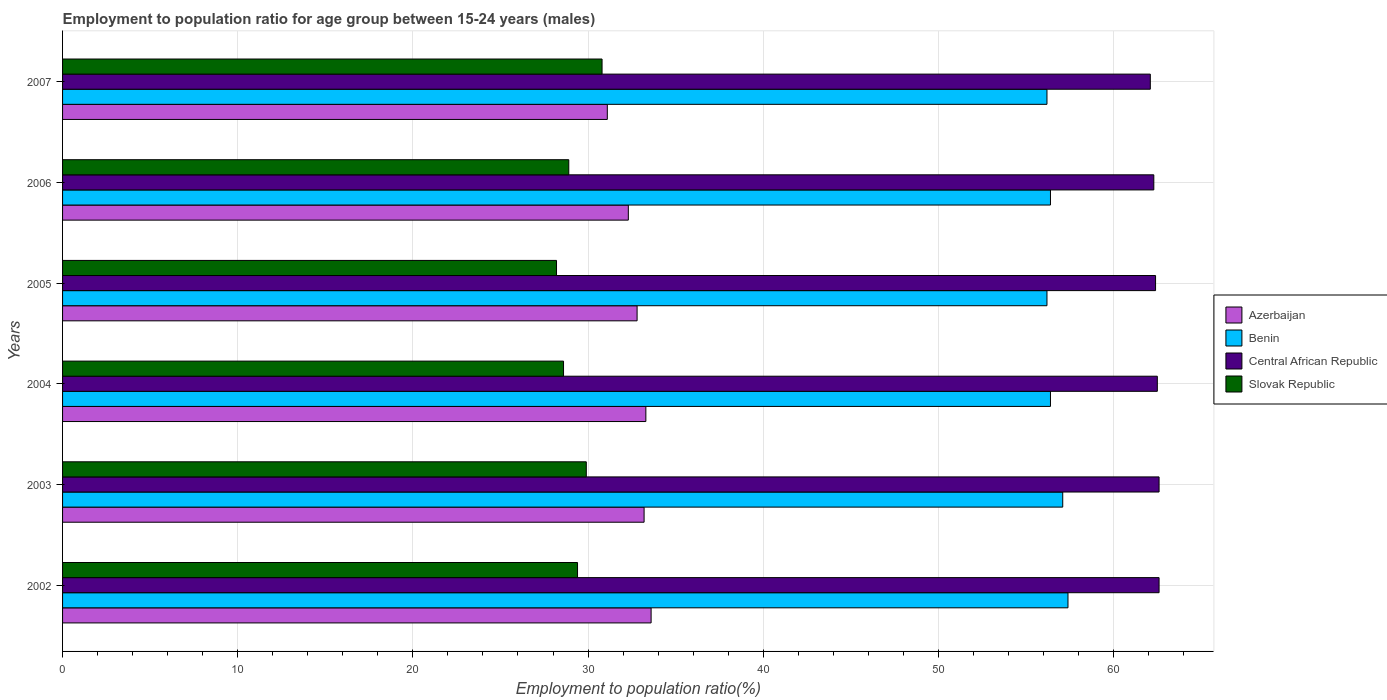Are the number of bars per tick equal to the number of legend labels?
Your response must be concise. Yes. In how many cases, is the number of bars for a given year not equal to the number of legend labels?
Ensure brevity in your answer.  0. What is the employment to population ratio in Benin in 2003?
Offer a very short reply. 57.1. Across all years, what is the maximum employment to population ratio in Azerbaijan?
Your response must be concise. 33.6. Across all years, what is the minimum employment to population ratio in Benin?
Your answer should be compact. 56.2. In which year was the employment to population ratio in Slovak Republic minimum?
Provide a succinct answer. 2005. What is the total employment to population ratio in Azerbaijan in the graph?
Give a very brief answer. 196.3. What is the difference between the employment to population ratio in Slovak Republic in 2003 and that in 2006?
Give a very brief answer. 1. What is the difference between the employment to population ratio in Central African Republic in 2007 and the employment to population ratio in Benin in 2002?
Offer a very short reply. 4.7. What is the average employment to population ratio in Benin per year?
Keep it short and to the point. 56.62. In the year 2007, what is the difference between the employment to population ratio in Slovak Republic and employment to population ratio in Benin?
Your answer should be very brief. -25.4. Is the difference between the employment to population ratio in Slovak Republic in 2002 and 2005 greater than the difference between the employment to population ratio in Benin in 2002 and 2005?
Offer a very short reply. No. What is the difference between the highest and the second highest employment to population ratio in Azerbaijan?
Offer a very short reply. 0.3. In how many years, is the employment to population ratio in Slovak Republic greater than the average employment to population ratio in Slovak Republic taken over all years?
Offer a terse response. 3. Is the sum of the employment to population ratio in Benin in 2004 and 2006 greater than the maximum employment to population ratio in Central African Republic across all years?
Your answer should be very brief. Yes. What does the 4th bar from the top in 2007 represents?
Your answer should be very brief. Azerbaijan. What does the 1st bar from the bottom in 2004 represents?
Your answer should be compact. Azerbaijan. Is it the case that in every year, the sum of the employment to population ratio in Central African Republic and employment to population ratio in Azerbaijan is greater than the employment to population ratio in Benin?
Offer a terse response. Yes. How many bars are there?
Ensure brevity in your answer.  24. Are the values on the major ticks of X-axis written in scientific E-notation?
Offer a very short reply. No. Does the graph contain grids?
Your answer should be very brief. Yes. Where does the legend appear in the graph?
Give a very brief answer. Center right. How are the legend labels stacked?
Give a very brief answer. Vertical. What is the title of the graph?
Provide a short and direct response. Employment to population ratio for age group between 15-24 years (males). What is the label or title of the X-axis?
Provide a short and direct response. Employment to population ratio(%). What is the Employment to population ratio(%) of Azerbaijan in 2002?
Offer a terse response. 33.6. What is the Employment to population ratio(%) of Benin in 2002?
Keep it short and to the point. 57.4. What is the Employment to population ratio(%) in Central African Republic in 2002?
Your response must be concise. 62.6. What is the Employment to population ratio(%) of Slovak Republic in 2002?
Offer a very short reply. 29.4. What is the Employment to population ratio(%) in Azerbaijan in 2003?
Your answer should be compact. 33.2. What is the Employment to population ratio(%) of Benin in 2003?
Provide a short and direct response. 57.1. What is the Employment to population ratio(%) in Central African Republic in 2003?
Keep it short and to the point. 62.6. What is the Employment to population ratio(%) of Slovak Republic in 2003?
Your response must be concise. 29.9. What is the Employment to population ratio(%) of Azerbaijan in 2004?
Your answer should be very brief. 33.3. What is the Employment to population ratio(%) of Benin in 2004?
Your answer should be very brief. 56.4. What is the Employment to population ratio(%) in Central African Republic in 2004?
Offer a terse response. 62.5. What is the Employment to population ratio(%) of Slovak Republic in 2004?
Provide a succinct answer. 28.6. What is the Employment to population ratio(%) of Azerbaijan in 2005?
Keep it short and to the point. 32.8. What is the Employment to population ratio(%) in Benin in 2005?
Your answer should be compact. 56.2. What is the Employment to population ratio(%) in Central African Republic in 2005?
Provide a succinct answer. 62.4. What is the Employment to population ratio(%) in Slovak Republic in 2005?
Provide a succinct answer. 28.2. What is the Employment to population ratio(%) of Azerbaijan in 2006?
Keep it short and to the point. 32.3. What is the Employment to population ratio(%) of Benin in 2006?
Offer a very short reply. 56.4. What is the Employment to population ratio(%) in Central African Republic in 2006?
Offer a very short reply. 62.3. What is the Employment to population ratio(%) of Slovak Republic in 2006?
Provide a succinct answer. 28.9. What is the Employment to population ratio(%) in Azerbaijan in 2007?
Provide a succinct answer. 31.1. What is the Employment to population ratio(%) of Benin in 2007?
Offer a terse response. 56.2. What is the Employment to population ratio(%) in Central African Republic in 2007?
Offer a terse response. 62.1. What is the Employment to population ratio(%) in Slovak Republic in 2007?
Your response must be concise. 30.8. Across all years, what is the maximum Employment to population ratio(%) of Azerbaijan?
Provide a succinct answer. 33.6. Across all years, what is the maximum Employment to population ratio(%) of Benin?
Your answer should be very brief. 57.4. Across all years, what is the maximum Employment to population ratio(%) of Central African Republic?
Your answer should be very brief. 62.6. Across all years, what is the maximum Employment to population ratio(%) in Slovak Republic?
Keep it short and to the point. 30.8. Across all years, what is the minimum Employment to population ratio(%) of Azerbaijan?
Your answer should be compact. 31.1. Across all years, what is the minimum Employment to population ratio(%) of Benin?
Give a very brief answer. 56.2. Across all years, what is the minimum Employment to population ratio(%) in Central African Republic?
Provide a succinct answer. 62.1. Across all years, what is the minimum Employment to population ratio(%) in Slovak Republic?
Provide a short and direct response. 28.2. What is the total Employment to population ratio(%) of Azerbaijan in the graph?
Offer a very short reply. 196.3. What is the total Employment to population ratio(%) in Benin in the graph?
Offer a very short reply. 339.7. What is the total Employment to population ratio(%) of Central African Republic in the graph?
Offer a very short reply. 374.5. What is the total Employment to population ratio(%) in Slovak Republic in the graph?
Offer a very short reply. 175.8. What is the difference between the Employment to population ratio(%) in Azerbaijan in 2002 and that in 2003?
Ensure brevity in your answer.  0.4. What is the difference between the Employment to population ratio(%) of Slovak Republic in 2002 and that in 2003?
Keep it short and to the point. -0.5. What is the difference between the Employment to population ratio(%) of Benin in 2002 and that in 2004?
Provide a succinct answer. 1. What is the difference between the Employment to population ratio(%) in Central African Republic in 2002 and that in 2005?
Offer a terse response. 0.2. What is the difference between the Employment to population ratio(%) in Slovak Republic in 2002 and that in 2005?
Your response must be concise. 1.2. What is the difference between the Employment to population ratio(%) in Benin in 2002 and that in 2006?
Ensure brevity in your answer.  1. What is the difference between the Employment to population ratio(%) in Central African Republic in 2002 and that in 2006?
Your answer should be compact. 0.3. What is the difference between the Employment to population ratio(%) of Slovak Republic in 2002 and that in 2006?
Your response must be concise. 0.5. What is the difference between the Employment to population ratio(%) of Benin in 2003 and that in 2004?
Your response must be concise. 0.7. What is the difference between the Employment to population ratio(%) in Central African Republic in 2003 and that in 2004?
Your answer should be very brief. 0.1. What is the difference between the Employment to population ratio(%) in Azerbaijan in 2003 and that in 2005?
Your answer should be compact. 0.4. What is the difference between the Employment to population ratio(%) in Benin in 2003 and that in 2005?
Keep it short and to the point. 0.9. What is the difference between the Employment to population ratio(%) of Central African Republic in 2003 and that in 2005?
Keep it short and to the point. 0.2. What is the difference between the Employment to population ratio(%) of Azerbaijan in 2003 and that in 2006?
Keep it short and to the point. 0.9. What is the difference between the Employment to population ratio(%) in Central African Republic in 2003 and that in 2006?
Provide a succinct answer. 0.3. What is the difference between the Employment to population ratio(%) in Benin in 2003 and that in 2007?
Your answer should be very brief. 0.9. What is the difference between the Employment to population ratio(%) in Central African Republic in 2003 and that in 2007?
Provide a succinct answer. 0.5. What is the difference between the Employment to population ratio(%) of Slovak Republic in 2003 and that in 2007?
Your response must be concise. -0.9. What is the difference between the Employment to population ratio(%) of Benin in 2004 and that in 2005?
Your answer should be very brief. 0.2. What is the difference between the Employment to population ratio(%) in Central African Republic in 2004 and that in 2005?
Offer a terse response. 0.1. What is the difference between the Employment to population ratio(%) in Benin in 2004 and that in 2006?
Provide a succinct answer. 0. What is the difference between the Employment to population ratio(%) in Central African Republic in 2004 and that in 2006?
Your answer should be very brief. 0.2. What is the difference between the Employment to population ratio(%) in Azerbaijan in 2004 and that in 2007?
Your answer should be very brief. 2.2. What is the difference between the Employment to population ratio(%) of Central African Republic in 2004 and that in 2007?
Make the answer very short. 0.4. What is the difference between the Employment to population ratio(%) of Azerbaijan in 2005 and that in 2006?
Offer a very short reply. 0.5. What is the difference between the Employment to population ratio(%) in Benin in 2005 and that in 2006?
Offer a very short reply. -0.2. What is the difference between the Employment to population ratio(%) of Slovak Republic in 2005 and that in 2006?
Provide a succinct answer. -0.7. What is the difference between the Employment to population ratio(%) of Benin in 2005 and that in 2007?
Make the answer very short. 0. What is the difference between the Employment to population ratio(%) of Slovak Republic in 2005 and that in 2007?
Provide a short and direct response. -2.6. What is the difference between the Employment to population ratio(%) of Benin in 2006 and that in 2007?
Keep it short and to the point. 0.2. What is the difference between the Employment to population ratio(%) in Central African Republic in 2006 and that in 2007?
Offer a very short reply. 0.2. What is the difference between the Employment to population ratio(%) of Slovak Republic in 2006 and that in 2007?
Keep it short and to the point. -1.9. What is the difference between the Employment to population ratio(%) in Azerbaijan in 2002 and the Employment to population ratio(%) in Benin in 2003?
Ensure brevity in your answer.  -23.5. What is the difference between the Employment to population ratio(%) of Azerbaijan in 2002 and the Employment to population ratio(%) of Central African Republic in 2003?
Make the answer very short. -29. What is the difference between the Employment to population ratio(%) of Benin in 2002 and the Employment to population ratio(%) of Slovak Republic in 2003?
Keep it short and to the point. 27.5. What is the difference between the Employment to population ratio(%) of Central African Republic in 2002 and the Employment to population ratio(%) of Slovak Republic in 2003?
Your answer should be compact. 32.7. What is the difference between the Employment to population ratio(%) of Azerbaijan in 2002 and the Employment to population ratio(%) of Benin in 2004?
Ensure brevity in your answer.  -22.8. What is the difference between the Employment to population ratio(%) in Azerbaijan in 2002 and the Employment to population ratio(%) in Central African Republic in 2004?
Your answer should be compact. -28.9. What is the difference between the Employment to population ratio(%) in Benin in 2002 and the Employment to population ratio(%) in Central African Republic in 2004?
Make the answer very short. -5.1. What is the difference between the Employment to population ratio(%) of Benin in 2002 and the Employment to population ratio(%) of Slovak Republic in 2004?
Offer a terse response. 28.8. What is the difference between the Employment to population ratio(%) of Central African Republic in 2002 and the Employment to population ratio(%) of Slovak Republic in 2004?
Offer a very short reply. 34. What is the difference between the Employment to population ratio(%) of Azerbaijan in 2002 and the Employment to population ratio(%) of Benin in 2005?
Offer a terse response. -22.6. What is the difference between the Employment to population ratio(%) in Azerbaijan in 2002 and the Employment to population ratio(%) in Central African Republic in 2005?
Keep it short and to the point. -28.8. What is the difference between the Employment to population ratio(%) in Azerbaijan in 2002 and the Employment to population ratio(%) in Slovak Republic in 2005?
Provide a short and direct response. 5.4. What is the difference between the Employment to population ratio(%) of Benin in 2002 and the Employment to population ratio(%) of Central African Republic in 2005?
Your response must be concise. -5. What is the difference between the Employment to population ratio(%) in Benin in 2002 and the Employment to population ratio(%) in Slovak Republic in 2005?
Offer a terse response. 29.2. What is the difference between the Employment to population ratio(%) of Central African Republic in 2002 and the Employment to population ratio(%) of Slovak Republic in 2005?
Ensure brevity in your answer.  34.4. What is the difference between the Employment to population ratio(%) of Azerbaijan in 2002 and the Employment to population ratio(%) of Benin in 2006?
Provide a succinct answer. -22.8. What is the difference between the Employment to population ratio(%) in Azerbaijan in 2002 and the Employment to population ratio(%) in Central African Republic in 2006?
Your answer should be compact. -28.7. What is the difference between the Employment to population ratio(%) of Azerbaijan in 2002 and the Employment to population ratio(%) of Slovak Republic in 2006?
Your response must be concise. 4.7. What is the difference between the Employment to population ratio(%) in Benin in 2002 and the Employment to population ratio(%) in Slovak Republic in 2006?
Keep it short and to the point. 28.5. What is the difference between the Employment to population ratio(%) of Central African Republic in 2002 and the Employment to population ratio(%) of Slovak Republic in 2006?
Give a very brief answer. 33.7. What is the difference between the Employment to population ratio(%) of Azerbaijan in 2002 and the Employment to population ratio(%) of Benin in 2007?
Your answer should be compact. -22.6. What is the difference between the Employment to population ratio(%) in Azerbaijan in 2002 and the Employment to population ratio(%) in Central African Republic in 2007?
Give a very brief answer. -28.5. What is the difference between the Employment to population ratio(%) of Azerbaijan in 2002 and the Employment to population ratio(%) of Slovak Republic in 2007?
Ensure brevity in your answer.  2.8. What is the difference between the Employment to population ratio(%) of Benin in 2002 and the Employment to population ratio(%) of Slovak Republic in 2007?
Make the answer very short. 26.6. What is the difference between the Employment to population ratio(%) in Central African Republic in 2002 and the Employment to population ratio(%) in Slovak Republic in 2007?
Offer a very short reply. 31.8. What is the difference between the Employment to population ratio(%) in Azerbaijan in 2003 and the Employment to population ratio(%) in Benin in 2004?
Offer a very short reply. -23.2. What is the difference between the Employment to population ratio(%) of Azerbaijan in 2003 and the Employment to population ratio(%) of Central African Republic in 2004?
Offer a very short reply. -29.3. What is the difference between the Employment to population ratio(%) in Azerbaijan in 2003 and the Employment to population ratio(%) in Slovak Republic in 2004?
Your answer should be very brief. 4.6. What is the difference between the Employment to population ratio(%) in Benin in 2003 and the Employment to population ratio(%) in Central African Republic in 2004?
Your answer should be compact. -5.4. What is the difference between the Employment to population ratio(%) in Azerbaijan in 2003 and the Employment to population ratio(%) in Benin in 2005?
Your response must be concise. -23. What is the difference between the Employment to population ratio(%) in Azerbaijan in 2003 and the Employment to population ratio(%) in Central African Republic in 2005?
Ensure brevity in your answer.  -29.2. What is the difference between the Employment to population ratio(%) in Azerbaijan in 2003 and the Employment to population ratio(%) in Slovak Republic in 2005?
Your response must be concise. 5. What is the difference between the Employment to population ratio(%) of Benin in 2003 and the Employment to population ratio(%) of Slovak Republic in 2005?
Give a very brief answer. 28.9. What is the difference between the Employment to population ratio(%) in Central African Republic in 2003 and the Employment to population ratio(%) in Slovak Republic in 2005?
Provide a succinct answer. 34.4. What is the difference between the Employment to population ratio(%) of Azerbaijan in 2003 and the Employment to population ratio(%) of Benin in 2006?
Your response must be concise. -23.2. What is the difference between the Employment to population ratio(%) in Azerbaijan in 2003 and the Employment to population ratio(%) in Central African Republic in 2006?
Give a very brief answer. -29.1. What is the difference between the Employment to population ratio(%) of Benin in 2003 and the Employment to population ratio(%) of Slovak Republic in 2006?
Your response must be concise. 28.2. What is the difference between the Employment to population ratio(%) in Central African Republic in 2003 and the Employment to population ratio(%) in Slovak Republic in 2006?
Your response must be concise. 33.7. What is the difference between the Employment to population ratio(%) in Azerbaijan in 2003 and the Employment to population ratio(%) in Benin in 2007?
Offer a terse response. -23. What is the difference between the Employment to population ratio(%) of Azerbaijan in 2003 and the Employment to population ratio(%) of Central African Republic in 2007?
Your response must be concise. -28.9. What is the difference between the Employment to population ratio(%) in Benin in 2003 and the Employment to population ratio(%) in Slovak Republic in 2007?
Provide a succinct answer. 26.3. What is the difference between the Employment to population ratio(%) in Central African Republic in 2003 and the Employment to population ratio(%) in Slovak Republic in 2007?
Offer a very short reply. 31.8. What is the difference between the Employment to population ratio(%) of Azerbaijan in 2004 and the Employment to population ratio(%) of Benin in 2005?
Your response must be concise. -22.9. What is the difference between the Employment to population ratio(%) in Azerbaijan in 2004 and the Employment to population ratio(%) in Central African Republic in 2005?
Give a very brief answer. -29.1. What is the difference between the Employment to population ratio(%) in Benin in 2004 and the Employment to population ratio(%) in Central African Republic in 2005?
Make the answer very short. -6. What is the difference between the Employment to population ratio(%) of Benin in 2004 and the Employment to population ratio(%) of Slovak Republic in 2005?
Ensure brevity in your answer.  28.2. What is the difference between the Employment to population ratio(%) of Central African Republic in 2004 and the Employment to population ratio(%) of Slovak Republic in 2005?
Your response must be concise. 34.3. What is the difference between the Employment to population ratio(%) in Azerbaijan in 2004 and the Employment to population ratio(%) in Benin in 2006?
Your answer should be compact. -23.1. What is the difference between the Employment to population ratio(%) in Azerbaijan in 2004 and the Employment to population ratio(%) in Slovak Republic in 2006?
Offer a very short reply. 4.4. What is the difference between the Employment to population ratio(%) in Benin in 2004 and the Employment to population ratio(%) in Central African Republic in 2006?
Your answer should be compact. -5.9. What is the difference between the Employment to population ratio(%) in Central African Republic in 2004 and the Employment to population ratio(%) in Slovak Republic in 2006?
Offer a very short reply. 33.6. What is the difference between the Employment to population ratio(%) in Azerbaijan in 2004 and the Employment to population ratio(%) in Benin in 2007?
Offer a terse response. -22.9. What is the difference between the Employment to population ratio(%) in Azerbaijan in 2004 and the Employment to population ratio(%) in Central African Republic in 2007?
Provide a short and direct response. -28.8. What is the difference between the Employment to population ratio(%) of Benin in 2004 and the Employment to population ratio(%) of Central African Republic in 2007?
Offer a terse response. -5.7. What is the difference between the Employment to population ratio(%) in Benin in 2004 and the Employment to population ratio(%) in Slovak Republic in 2007?
Your answer should be very brief. 25.6. What is the difference between the Employment to population ratio(%) in Central African Republic in 2004 and the Employment to population ratio(%) in Slovak Republic in 2007?
Provide a short and direct response. 31.7. What is the difference between the Employment to population ratio(%) in Azerbaijan in 2005 and the Employment to population ratio(%) in Benin in 2006?
Provide a succinct answer. -23.6. What is the difference between the Employment to population ratio(%) of Azerbaijan in 2005 and the Employment to population ratio(%) of Central African Republic in 2006?
Keep it short and to the point. -29.5. What is the difference between the Employment to population ratio(%) of Benin in 2005 and the Employment to population ratio(%) of Central African Republic in 2006?
Ensure brevity in your answer.  -6.1. What is the difference between the Employment to population ratio(%) in Benin in 2005 and the Employment to population ratio(%) in Slovak Republic in 2006?
Ensure brevity in your answer.  27.3. What is the difference between the Employment to population ratio(%) in Central African Republic in 2005 and the Employment to population ratio(%) in Slovak Republic in 2006?
Offer a terse response. 33.5. What is the difference between the Employment to population ratio(%) in Azerbaijan in 2005 and the Employment to population ratio(%) in Benin in 2007?
Keep it short and to the point. -23.4. What is the difference between the Employment to population ratio(%) in Azerbaijan in 2005 and the Employment to population ratio(%) in Central African Republic in 2007?
Keep it short and to the point. -29.3. What is the difference between the Employment to population ratio(%) of Benin in 2005 and the Employment to population ratio(%) of Central African Republic in 2007?
Your response must be concise. -5.9. What is the difference between the Employment to population ratio(%) of Benin in 2005 and the Employment to population ratio(%) of Slovak Republic in 2007?
Keep it short and to the point. 25.4. What is the difference between the Employment to population ratio(%) of Central African Republic in 2005 and the Employment to population ratio(%) of Slovak Republic in 2007?
Your answer should be very brief. 31.6. What is the difference between the Employment to population ratio(%) in Azerbaijan in 2006 and the Employment to population ratio(%) in Benin in 2007?
Make the answer very short. -23.9. What is the difference between the Employment to population ratio(%) of Azerbaijan in 2006 and the Employment to population ratio(%) of Central African Republic in 2007?
Your answer should be very brief. -29.8. What is the difference between the Employment to population ratio(%) of Azerbaijan in 2006 and the Employment to population ratio(%) of Slovak Republic in 2007?
Your answer should be very brief. 1.5. What is the difference between the Employment to population ratio(%) of Benin in 2006 and the Employment to population ratio(%) of Slovak Republic in 2007?
Provide a succinct answer. 25.6. What is the difference between the Employment to population ratio(%) of Central African Republic in 2006 and the Employment to population ratio(%) of Slovak Republic in 2007?
Give a very brief answer. 31.5. What is the average Employment to population ratio(%) in Azerbaijan per year?
Your response must be concise. 32.72. What is the average Employment to population ratio(%) of Benin per year?
Your response must be concise. 56.62. What is the average Employment to population ratio(%) of Central African Republic per year?
Offer a very short reply. 62.42. What is the average Employment to population ratio(%) of Slovak Republic per year?
Make the answer very short. 29.3. In the year 2002, what is the difference between the Employment to population ratio(%) in Azerbaijan and Employment to population ratio(%) in Benin?
Provide a succinct answer. -23.8. In the year 2002, what is the difference between the Employment to population ratio(%) in Benin and Employment to population ratio(%) in Slovak Republic?
Your answer should be very brief. 28. In the year 2002, what is the difference between the Employment to population ratio(%) of Central African Republic and Employment to population ratio(%) of Slovak Republic?
Your response must be concise. 33.2. In the year 2003, what is the difference between the Employment to population ratio(%) in Azerbaijan and Employment to population ratio(%) in Benin?
Make the answer very short. -23.9. In the year 2003, what is the difference between the Employment to population ratio(%) in Azerbaijan and Employment to population ratio(%) in Central African Republic?
Your answer should be compact. -29.4. In the year 2003, what is the difference between the Employment to population ratio(%) in Benin and Employment to population ratio(%) in Central African Republic?
Offer a very short reply. -5.5. In the year 2003, what is the difference between the Employment to population ratio(%) in Benin and Employment to population ratio(%) in Slovak Republic?
Provide a short and direct response. 27.2. In the year 2003, what is the difference between the Employment to population ratio(%) in Central African Republic and Employment to population ratio(%) in Slovak Republic?
Provide a succinct answer. 32.7. In the year 2004, what is the difference between the Employment to population ratio(%) of Azerbaijan and Employment to population ratio(%) of Benin?
Ensure brevity in your answer.  -23.1. In the year 2004, what is the difference between the Employment to population ratio(%) of Azerbaijan and Employment to population ratio(%) of Central African Republic?
Offer a very short reply. -29.2. In the year 2004, what is the difference between the Employment to population ratio(%) in Benin and Employment to population ratio(%) in Central African Republic?
Offer a very short reply. -6.1. In the year 2004, what is the difference between the Employment to population ratio(%) of Benin and Employment to population ratio(%) of Slovak Republic?
Your answer should be compact. 27.8. In the year 2004, what is the difference between the Employment to population ratio(%) of Central African Republic and Employment to population ratio(%) of Slovak Republic?
Provide a succinct answer. 33.9. In the year 2005, what is the difference between the Employment to population ratio(%) in Azerbaijan and Employment to population ratio(%) in Benin?
Offer a terse response. -23.4. In the year 2005, what is the difference between the Employment to population ratio(%) in Azerbaijan and Employment to population ratio(%) in Central African Republic?
Your answer should be very brief. -29.6. In the year 2005, what is the difference between the Employment to population ratio(%) in Azerbaijan and Employment to population ratio(%) in Slovak Republic?
Give a very brief answer. 4.6. In the year 2005, what is the difference between the Employment to population ratio(%) of Benin and Employment to population ratio(%) of Central African Republic?
Give a very brief answer. -6.2. In the year 2005, what is the difference between the Employment to population ratio(%) in Central African Republic and Employment to population ratio(%) in Slovak Republic?
Provide a succinct answer. 34.2. In the year 2006, what is the difference between the Employment to population ratio(%) of Azerbaijan and Employment to population ratio(%) of Benin?
Your answer should be very brief. -24.1. In the year 2006, what is the difference between the Employment to population ratio(%) of Azerbaijan and Employment to population ratio(%) of Slovak Republic?
Your response must be concise. 3.4. In the year 2006, what is the difference between the Employment to population ratio(%) in Benin and Employment to population ratio(%) in Central African Republic?
Your answer should be compact. -5.9. In the year 2006, what is the difference between the Employment to population ratio(%) in Central African Republic and Employment to population ratio(%) in Slovak Republic?
Offer a very short reply. 33.4. In the year 2007, what is the difference between the Employment to population ratio(%) of Azerbaijan and Employment to population ratio(%) of Benin?
Offer a very short reply. -25.1. In the year 2007, what is the difference between the Employment to population ratio(%) of Azerbaijan and Employment to population ratio(%) of Central African Republic?
Keep it short and to the point. -31. In the year 2007, what is the difference between the Employment to population ratio(%) of Azerbaijan and Employment to population ratio(%) of Slovak Republic?
Your response must be concise. 0.3. In the year 2007, what is the difference between the Employment to population ratio(%) in Benin and Employment to population ratio(%) in Central African Republic?
Your response must be concise. -5.9. In the year 2007, what is the difference between the Employment to population ratio(%) of Benin and Employment to population ratio(%) of Slovak Republic?
Your answer should be compact. 25.4. In the year 2007, what is the difference between the Employment to population ratio(%) in Central African Republic and Employment to population ratio(%) in Slovak Republic?
Provide a succinct answer. 31.3. What is the ratio of the Employment to population ratio(%) in Azerbaijan in 2002 to that in 2003?
Offer a very short reply. 1.01. What is the ratio of the Employment to population ratio(%) of Slovak Republic in 2002 to that in 2003?
Make the answer very short. 0.98. What is the ratio of the Employment to population ratio(%) of Azerbaijan in 2002 to that in 2004?
Offer a very short reply. 1.01. What is the ratio of the Employment to population ratio(%) in Benin in 2002 to that in 2004?
Keep it short and to the point. 1.02. What is the ratio of the Employment to population ratio(%) in Central African Republic in 2002 to that in 2004?
Make the answer very short. 1. What is the ratio of the Employment to population ratio(%) of Slovak Republic in 2002 to that in 2004?
Make the answer very short. 1.03. What is the ratio of the Employment to population ratio(%) of Azerbaijan in 2002 to that in 2005?
Make the answer very short. 1.02. What is the ratio of the Employment to population ratio(%) in Benin in 2002 to that in 2005?
Your answer should be compact. 1.02. What is the ratio of the Employment to population ratio(%) of Slovak Republic in 2002 to that in 2005?
Your response must be concise. 1.04. What is the ratio of the Employment to population ratio(%) in Azerbaijan in 2002 to that in 2006?
Your answer should be compact. 1.04. What is the ratio of the Employment to population ratio(%) in Benin in 2002 to that in 2006?
Provide a short and direct response. 1.02. What is the ratio of the Employment to population ratio(%) of Slovak Republic in 2002 to that in 2006?
Offer a terse response. 1.02. What is the ratio of the Employment to population ratio(%) of Azerbaijan in 2002 to that in 2007?
Give a very brief answer. 1.08. What is the ratio of the Employment to population ratio(%) of Benin in 2002 to that in 2007?
Keep it short and to the point. 1.02. What is the ratio of the Employment to population ratio(%) in Slovak Republic in 2002 to that in 2007?
Your response must be concise. 0.95. What is the ratio of the Employment to population ratio(%) in Benin in 2003 to that in 2004?
Offer a terse response. 1.01. What is the ratio of the Employment to population ratio(%) of Slovak Republic in 2003 to that in 2004?
Offer a very short reply. 1.05. What is the ratio of the Employment to population ratio(%) of Azerbaijan in 2003 to that in 2005?
Your answer should be compact. 1.01. What is the ratio of the Employment to population ratio(%) in Slovak Republic in 2003 to that in 2005?
Keep it short and to the point. 1.06. What is the ratio of the Employment to population ratio(%) in Azerbaijan in 2003 to that in 2006?
Offer a very short reply. 1.03. What is the ratio of the Employment to population ratio(%) in Benin in 2003 to that in 2006?
Provide a short and direct response. 1.01. What is the ratio of the Employment to population ratio(%) in Central African Republic in 2003 to that in 2006?
Provide a short and direct response. 1. What is the ratio of the Employment to population ratio(%) of Slovak Republic in 2003 to that in 2006?
Offer a very short reply. 1.03. What is the ratio of the Employment to population ratio(%) of Azerbaijan in 2003 to that in 2007?
Your answer should be very brief. 1.07. What is the ratio of the Employment to population ratio(%) of Slovak Republic in 2003 to that in 2007?
Provide a short and direct response. 0.97. What is the ratio of the Employment to population ratio(%) in Azerbaijan in 2004 to that in 2005?
Offer a terse response. 1.02. What is the ratio of the Employment to population ratio(%) of Central African Republic in 2004 to that in 2005?
Keep it short and to the point. 1. What is the ratio of the Employment to population ratio(%) in Slovak Republic in 2004 to that in 2005?
Offer a terse response. 1.01. What is the ratio of the Employment to population ratio(%) of Azerbaijan in 2004 to that in 2006?
Offer a terse response. 1.03. What is the ratio of the Employment to population ratio(%) in Azerbaijan in 2004 to that in 2007?
Provide a succinct answer. 1.07. What is the ratio of the Employment to population ratio(%) of Benin in 2004 to that in 2007?
Your answer should be very brief. 1. What is the ratio of the Employment to population ratio(%) in Central African Republic in 2004 to that in 2007?
Offer a terse response. 1.01. What is the ratio of the Employment to population ratio(%) in Slovak Republic in 2004 to that in 2007?
Provide a short and direct response. 0.93. What is the ratio of the Employment to population ratio(%) of Azerbaijan in 2005 to that in 2006?
Your answer should be compact. 1.02. What is the ratio of the Employment to population ratio(%) of Benin in 2005 to that in 2006?
Keep it short and to the point. 1. What is the ratio of the Employment to population ratio(%) in Slovak Republic in 2005 to that in 2006?
Your answer should be compact. 0.98. What is the ratio of the Employment to population ratio(%) of Azerbaijan in 2005 to that in 2007?
Give a very brief answer. 1.05. What is the ratio of the Employment to population ratio(%) in Slovak Republic in 2005 to that in 2007?
Give a very brief answer. 0.92. What is the ratio of the Employment to population ratio(%) of Azerbaijan in 2006 to that in 2007?
Give a very brief answer. 1.04. What is the ratio of the Employment to population ratio(%) of Benin in 2006 to that in 2007?
Make the answer very short. 1. What is the ratio of the Employment to population ratio(%) in Central African Republic in 2006 to that in 2007?
Give a very brief answer. 1. What is the ratio of the Employment to population ratio(%) in Slovak Republic in 2006 to that in 2007?
Offer a very short reply. 0.94. What is the difference between the highest and the second highest Employment to population ratio(%) in Azerbaijan?
Ensure brevity in your answer.  0.3. What is the difference between the highest and the second highest Employment to population ratio(%) of Benin?
Provide a short and direct response. 0.3. What is the difference between the highest and the second highest Employment to population ratio(%) in Central African Republic?
Provide a short and direct response. 0. What is the difference between the highest and the second highest Employment to population ratio(%) in Slovak Republic?
Your answer should be compact. 0.9. What is the difference between the highest and the lowest Employment to population ratio(%) of Azerbaijan?
Provide a succinct answer. 2.5. What is the difference between the highest and the lowest Employment to population ratio(%) of Central African Republic?
Give a very brief answer. 0.5. What is the difference between the highest and the lowest Employment to population ratio(%) of Slovak Republic?
Keep it short and to the point. 2.6. 